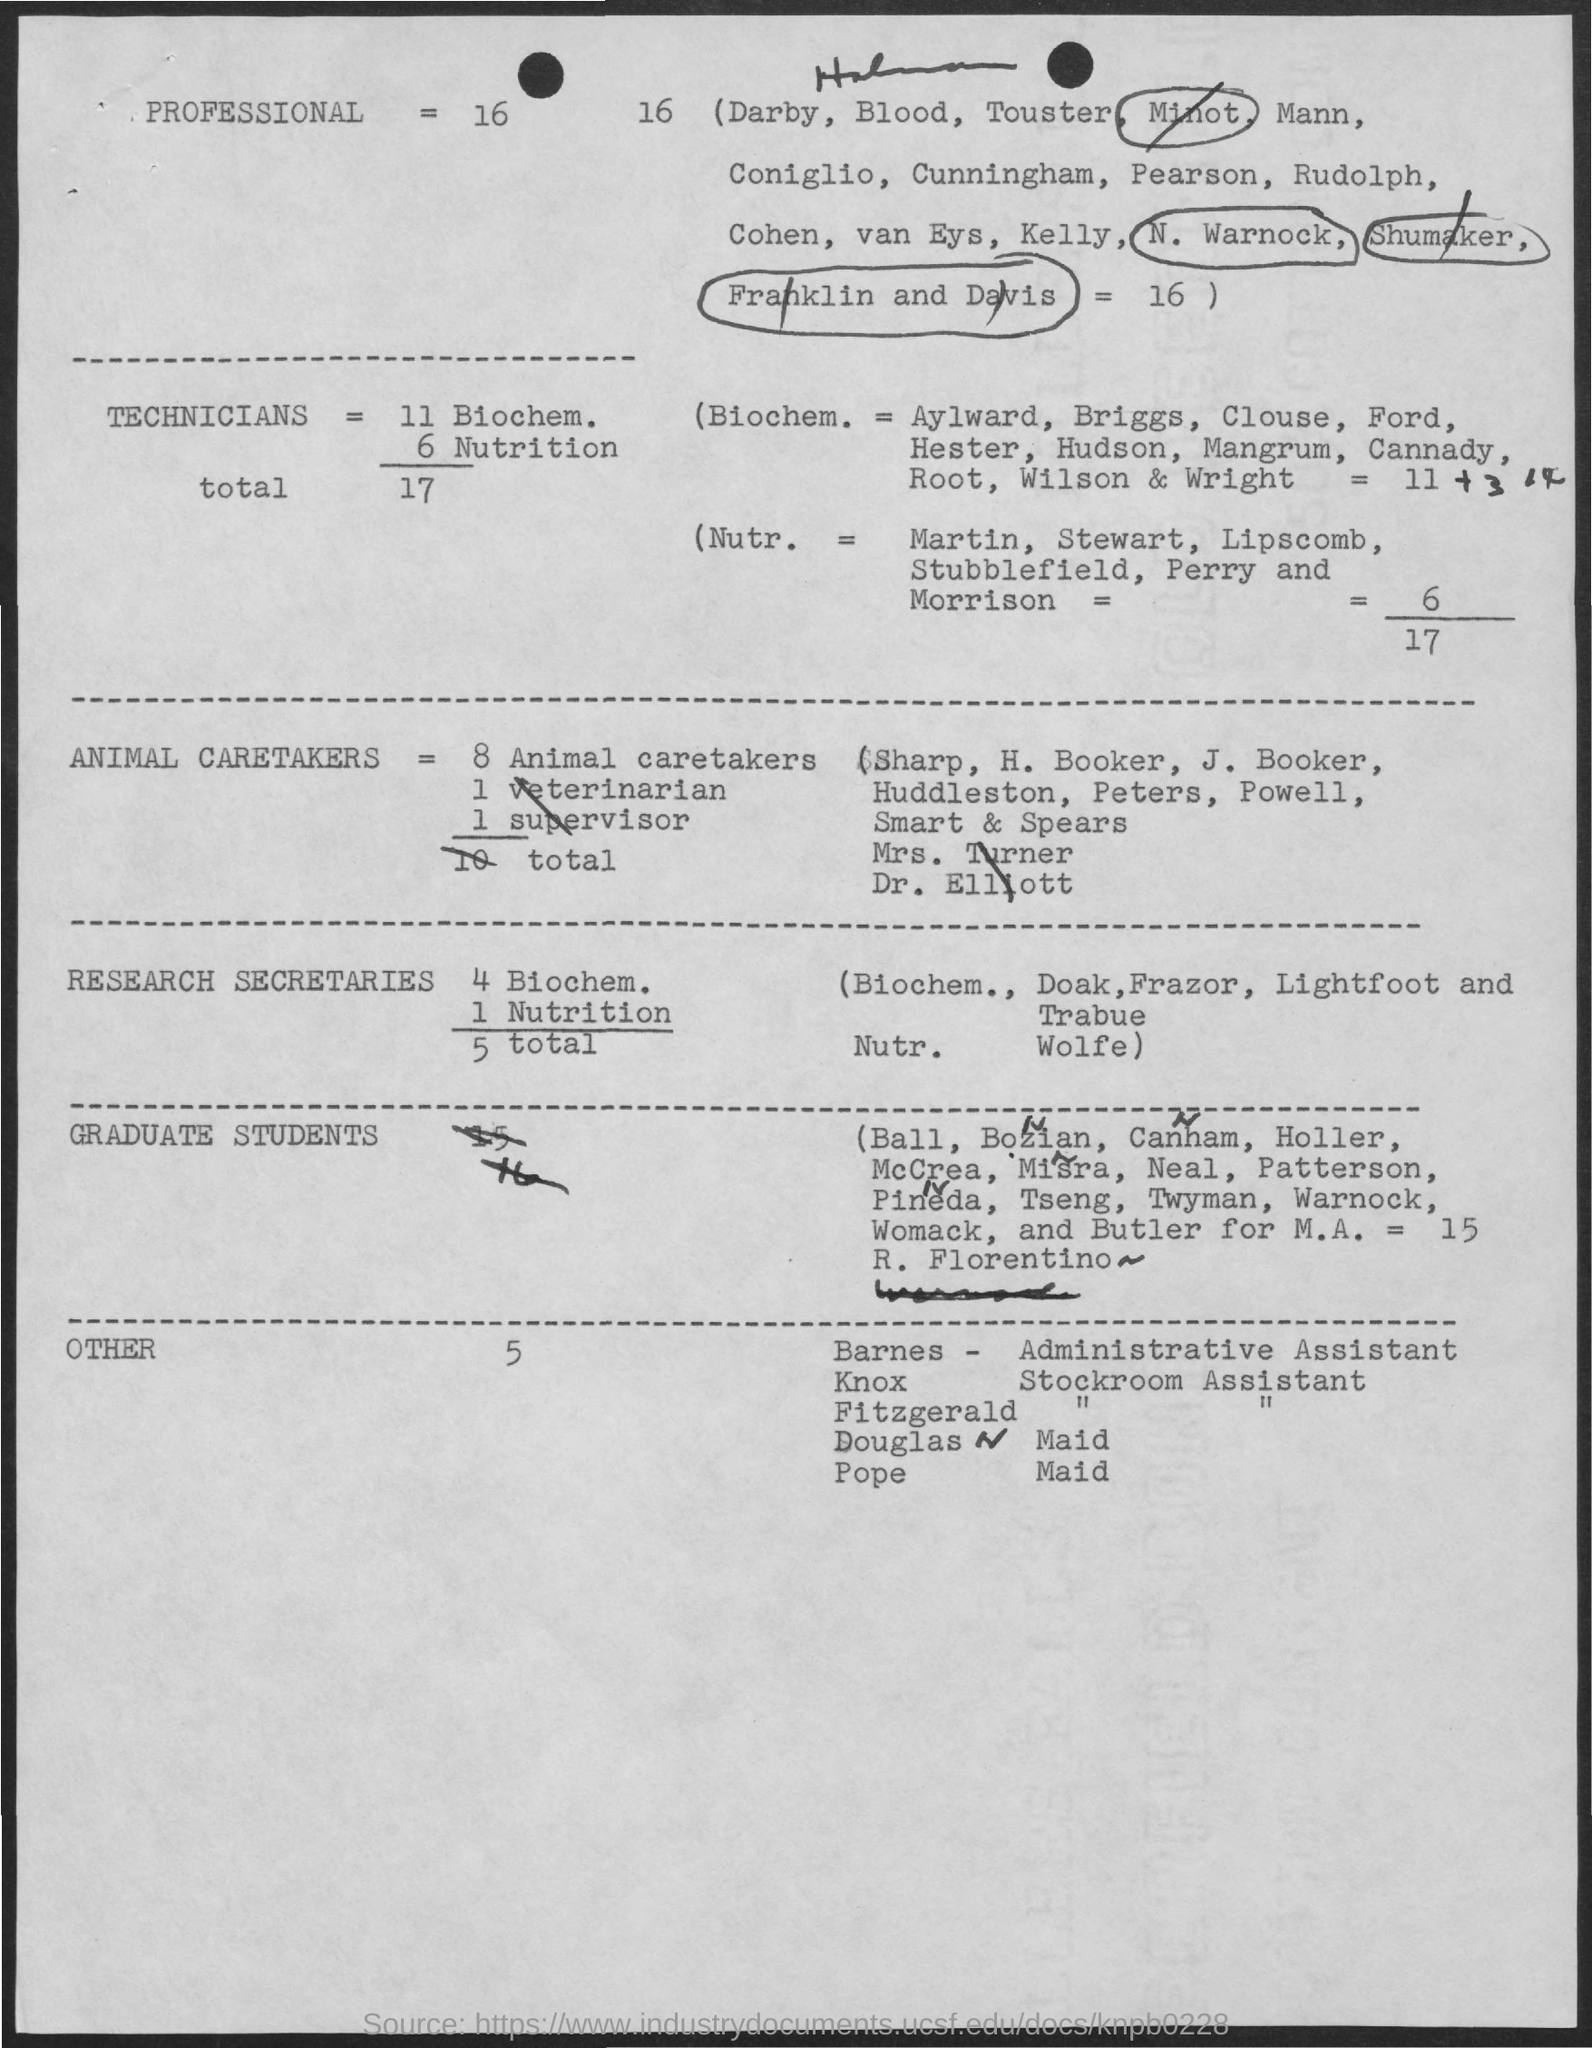What is the word circled in the first line?
Ensure brevity in your answer.  Minot. 